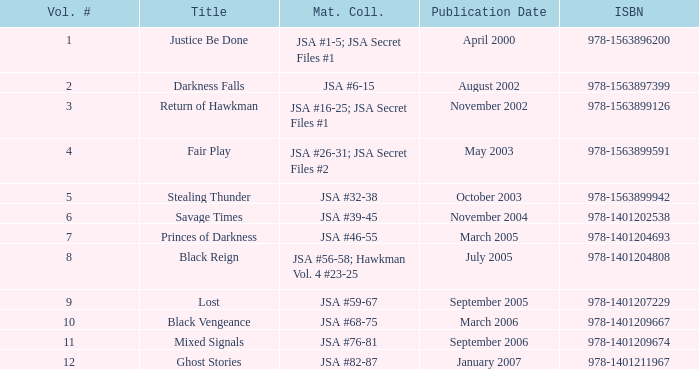What's the Lowest Volume Number that was published November 2004? 6.0. 